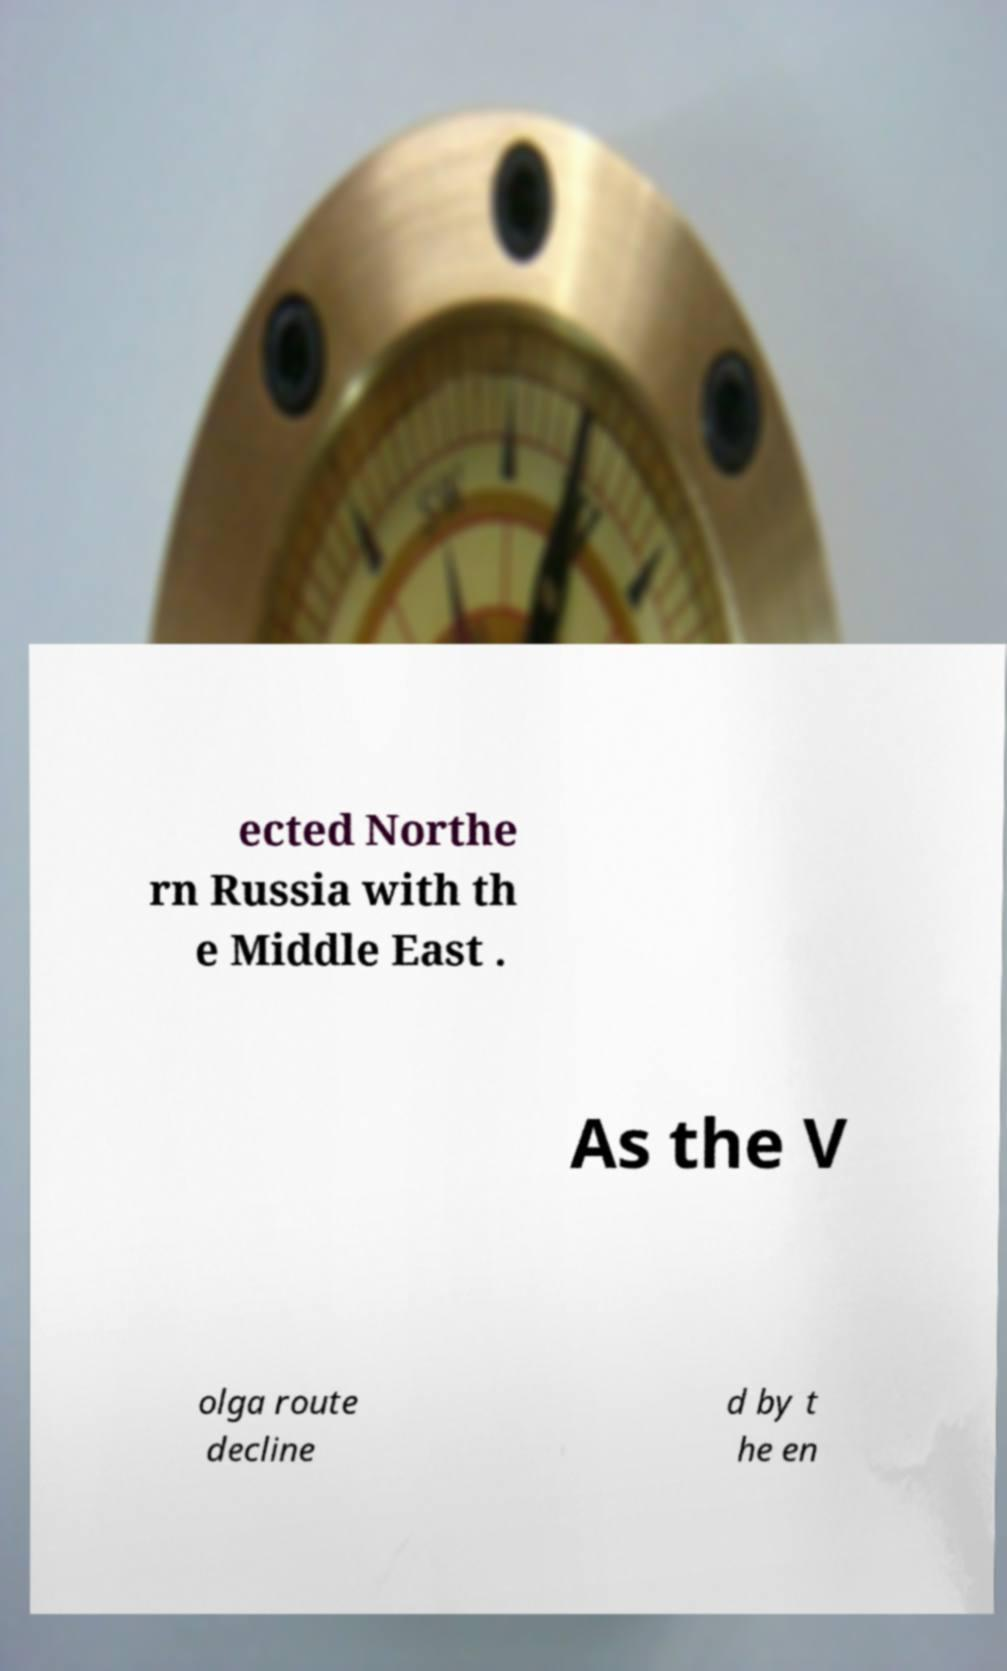What messages or text are displayed in this image? I need them in a readable, typed format. ected Northe rn Russia with th e Middle East . As the V olga route decline d by t he en 